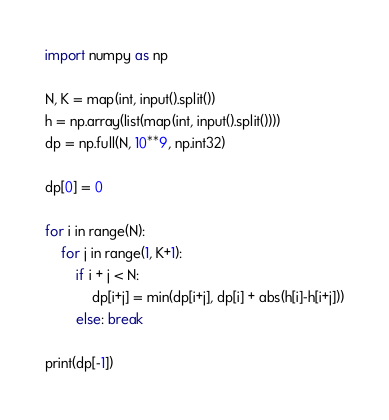<code> <loc_0><loc_0><loc_500><loc_500><_Python_>import numpy as np

N, K = map(int, input().split())
h = np.array(list(map(int, input().split())))
dp = np.full(N, 10**9, np.int32)

dp[0] = 0

for i in range(N):
	for j in range(1, K+1):
		if i + j < N:
			dp[i+j] = min(dp[i+j], dp[i] + abs(h[i]-h[i+j]))
		else: break

print(dp[-1])</code> 